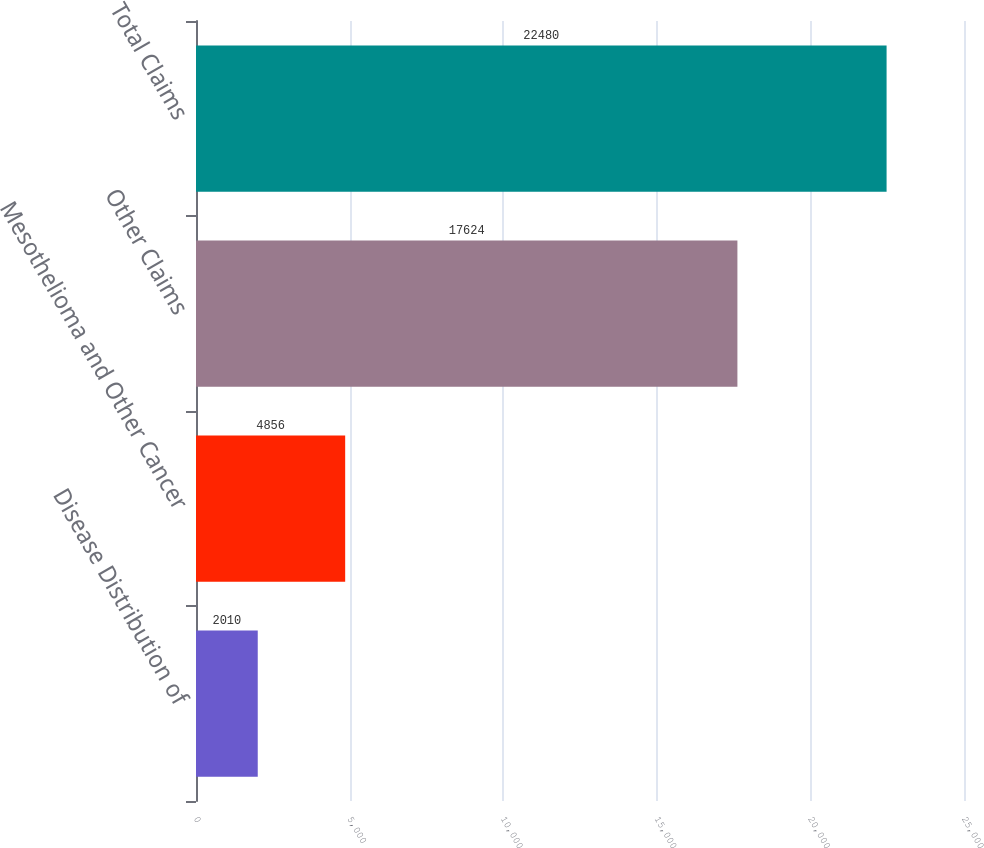Convert chart. <chart><loc_0><loc_0><loc_500><loc_500><bar_chart><fcel>Disease Distribution of<fcel>Mesothelioma and Other Cancer<fcel>Other Claims<fcel>Total Claims<nl><fcel>2010<fcel>4856<fcel>17624<fcel>22480<nl></chart> 